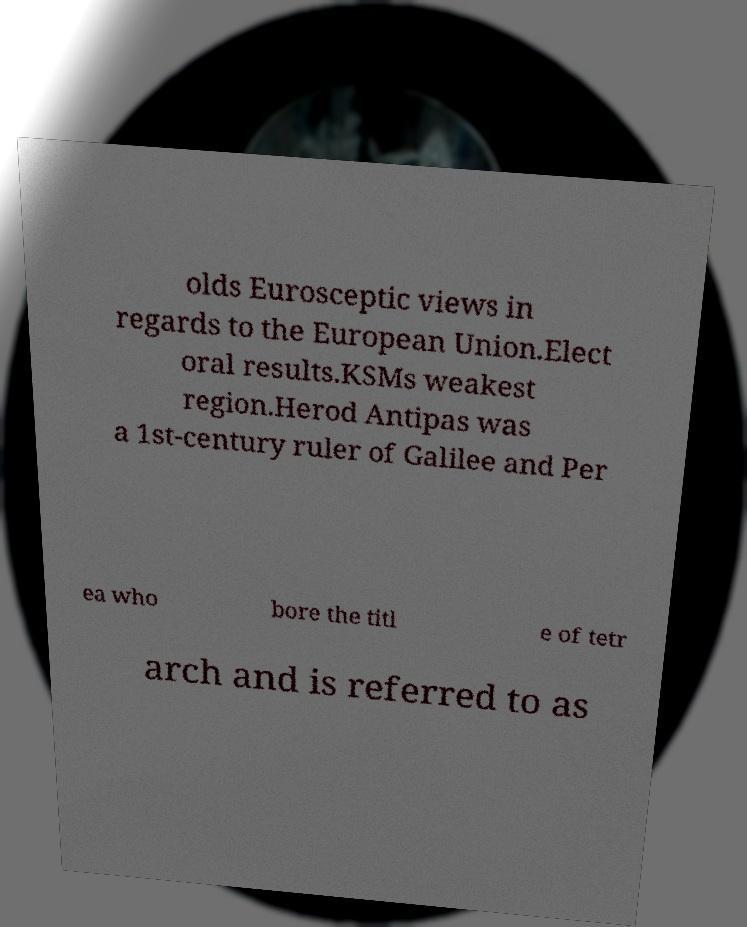I need the written content from this picture converted into text. Can you do that? olds Eurosceptic views in regards to the European Union.Elect oral results.KSMs weakest region.Herod Antipas was a 1st-century ruler of Galilee and Per ea who bore the titl e of tetr arch and is referred to as 